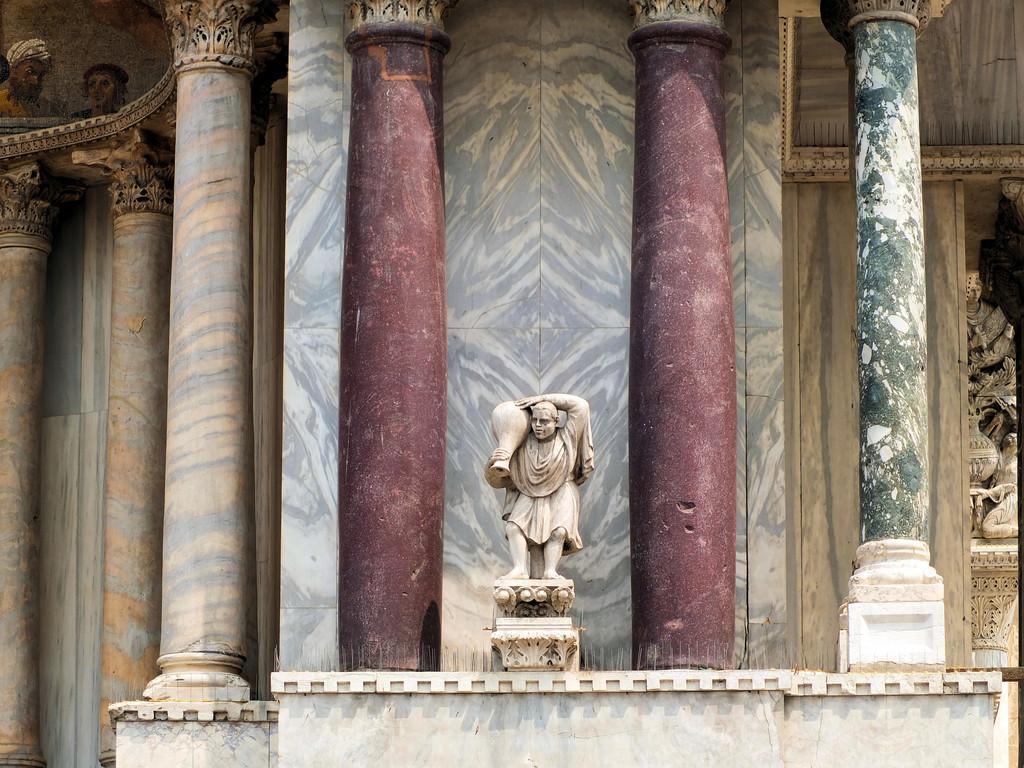Describe this image in one or two sentences. In the middle of this image there is a statue of a person. On both sides of this statue I can see the pillars. In the background there is a wall. 